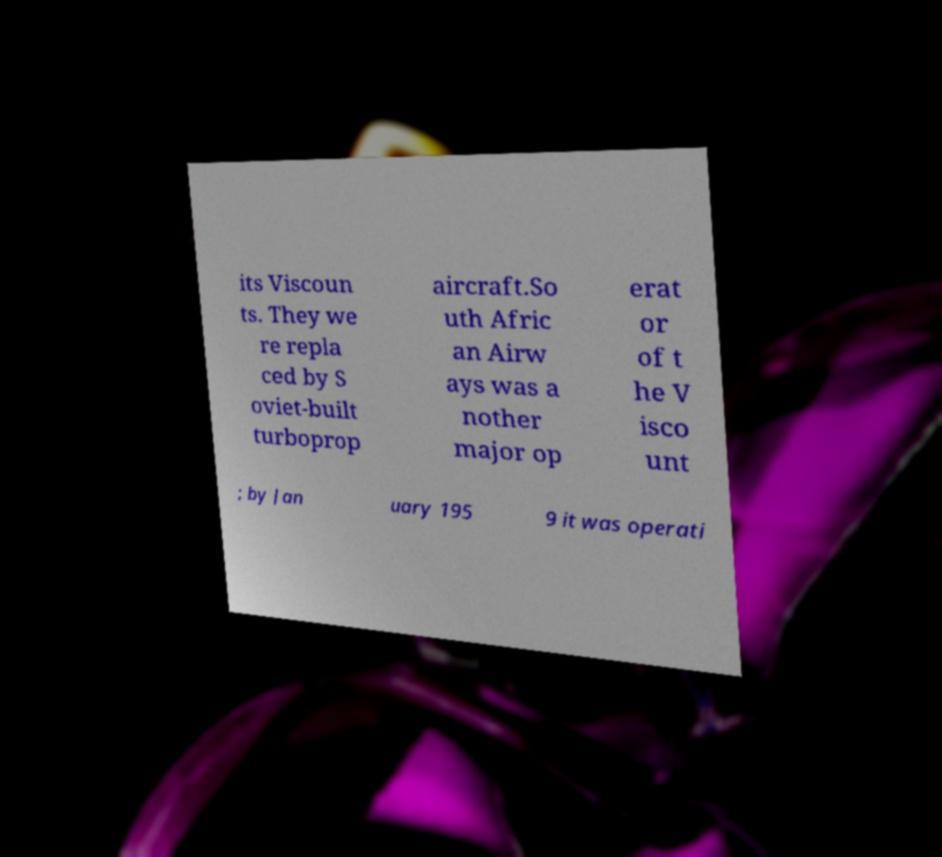I need the written content from this picture converted into text. Can you do that? its Viscoun ts. They we re repla ced by S oviet-built turboprop aircraft.So uth Afric an Airw ays was a nother major op erat or of t he V isco unt ; by Jan uary 195 9 it was operati 